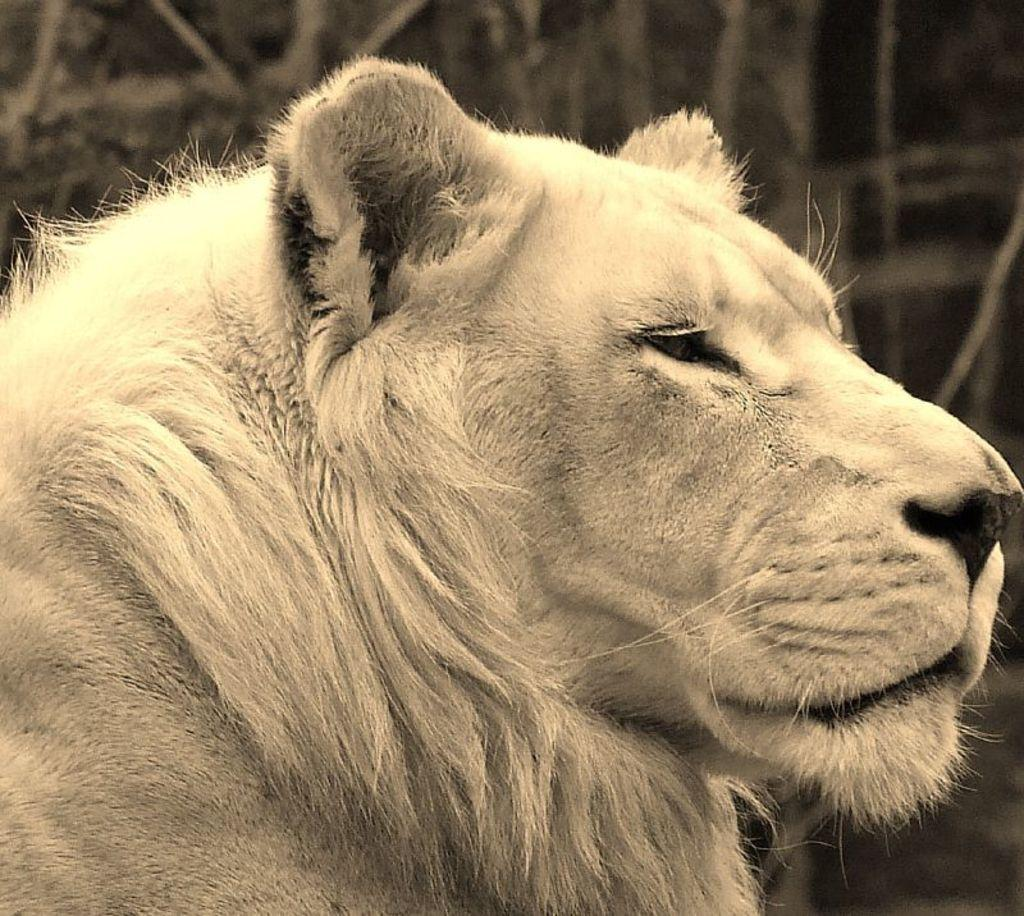What is the color scheme of the image? The image is black and white. What animal is featured in the image? There is a lion in the image. How many goldfish can be seen swimming in the image? There are no goldfish present in the image; it features a lion in a black and white color scheme. 